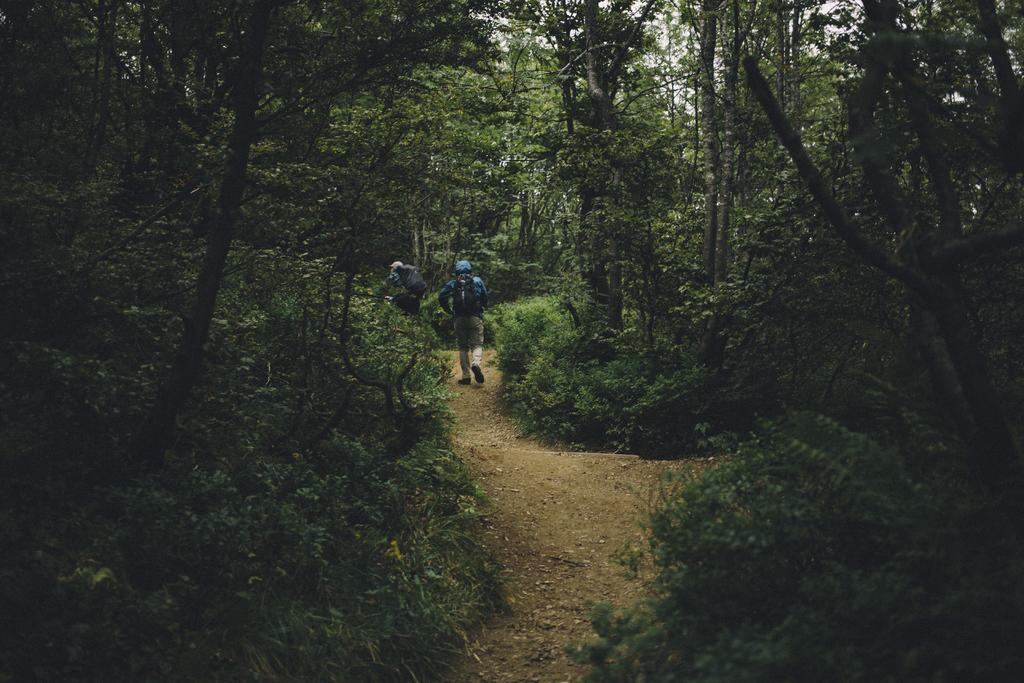How many people are in the image? There are two persons in the image. What are the persons carrying on their backs? The persons are carrying backpacks. What are the persons doing in the image? The persons are walking on a path. What can be seen in the background of the image? There are many trees around the place. What type of vegetable is being sorted by the persons in the image? There is no vegetable or sorting activity present in the image; the persons are walking on a path while carrying backpacks. 